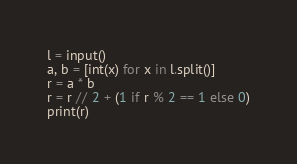Convert code to text. <code><loc_0><loc_0><loc_500><loc_500><_Python_>l = input()
a, b = [int(x) for x in l.split()]
r = a * b
r = r // 2 + (1 if r % 2 == 1 else 0)
print(r)
</code> 